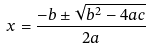<formula> <loc_0><loc_0><loc_500><loc_500>x = \frac { - b \pm \sqrt { b ^ { 2 } - 4 a c } } { 2 a }</formula> 